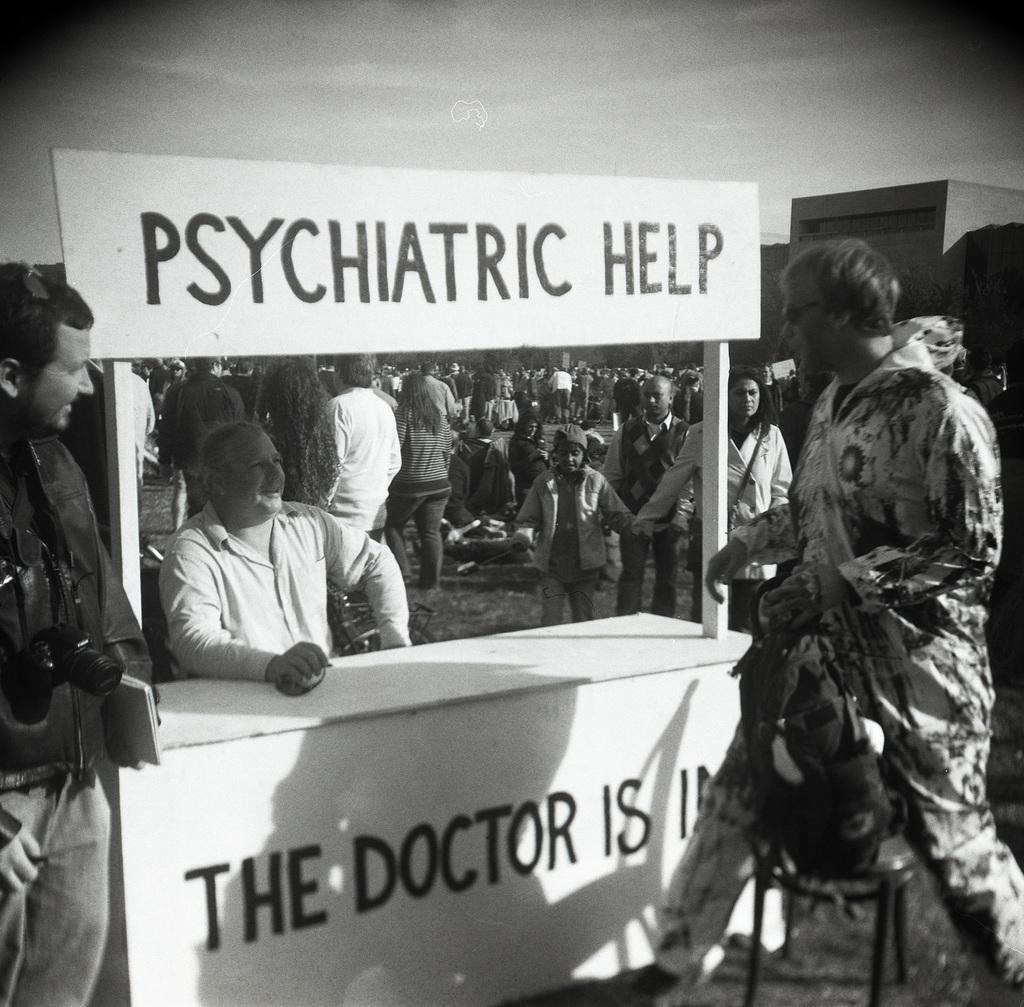Can you describe this image briefly? In this image I can see some people. I can see a board with some text written on it. In the background, I can see the building and the sky. I can also see the image is in black and white color. 